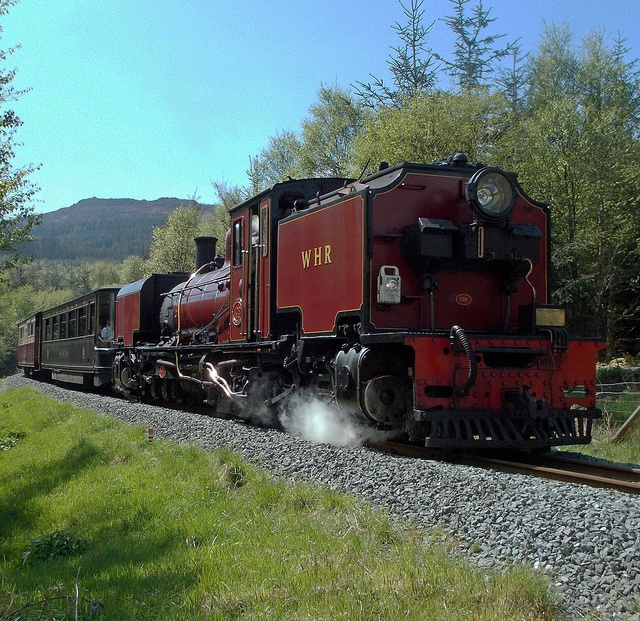Describe the objects in this image and their specific colors. I can see a train in gray, black, maroon, and darkgray tones in this image. 